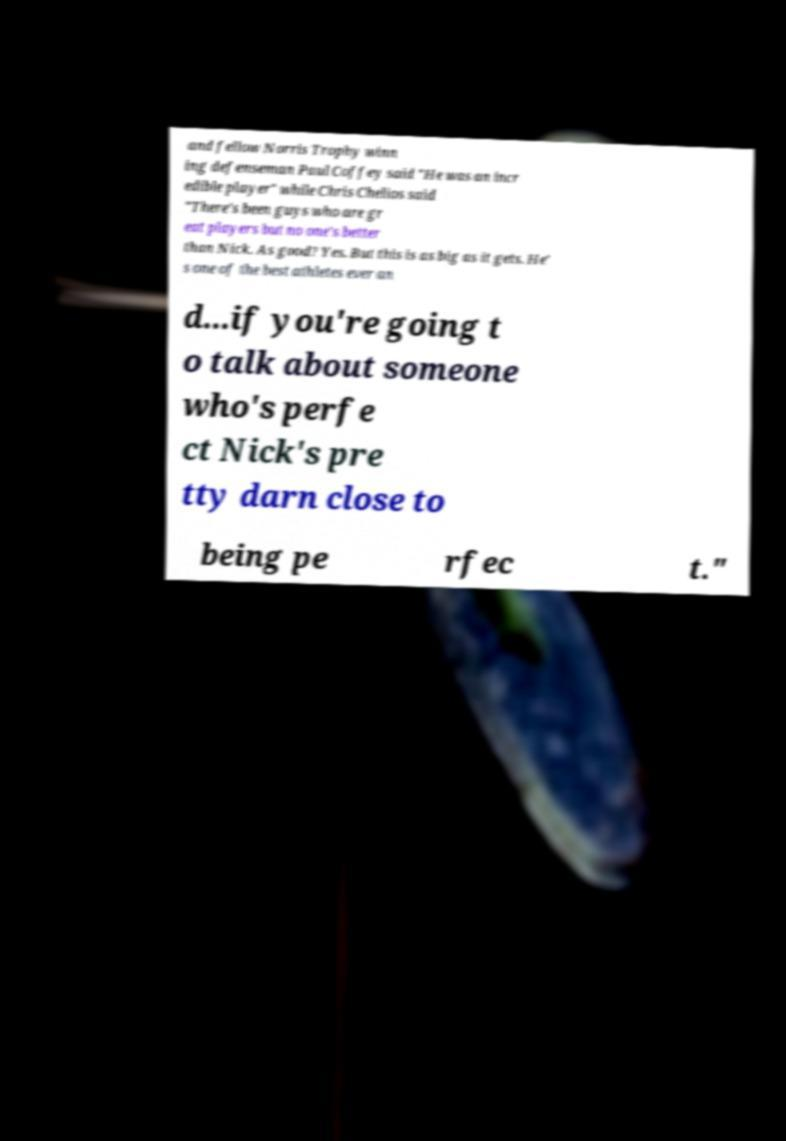I need the written content from this picture converted into text. Can you do that? and fellow Norris Trophy winn ing defenseman Paul Coffey said "He was an incr edible player" while Chris Chelios said "There's been guys who are gr eat players but no one's better than Nick. As good? Yes. But this is as big as it gets. He' s one of the best athletes ever an d...if you're going t o talk about someone who's perfe ct Nick's pre tty darn close to being pe rfec t." 